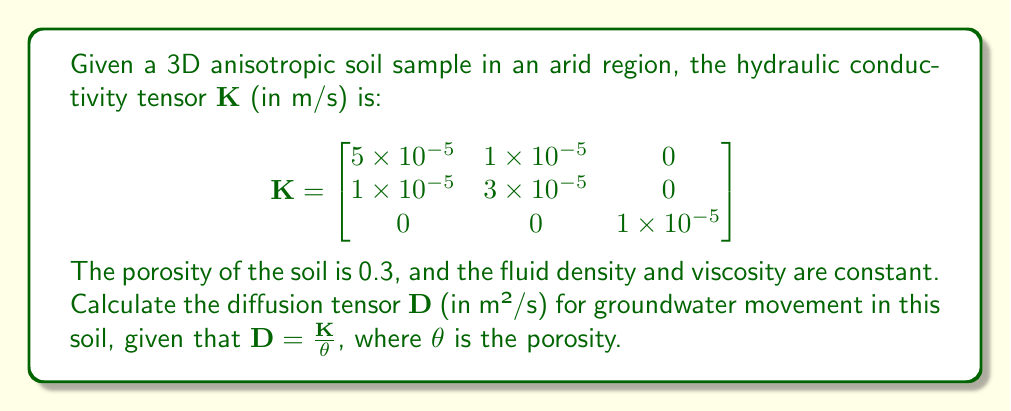Help me with this question. To solve this problem, we'll follow these steps:

1) Recall the relationship between the diffusion tensor $\mathbf{D}$ and the hydraulic conductivity tensor $\mathbf{K}$:

   $$\mathbf{D} = \frac{\mathbf{K}}{\theta}$$

   where $\theta$ is the porosity.

2) We're given that $\theta = 0.3$.

3) To calculate $\mathbf{D}$, we need to divide each element of $\mathbf{K}$ by $\theta$:

   $$\mathbf{D} = \frac{1}{0.3} \begin{bmatrix}
   5 \times 10^{-5} & 1 \times 10^{-5} & 0 \\
   1 \times 10^{-5} & 3 \times 10^{-5} & 0 \\
   0 & 0 & 1 \times 10^{-5}
   \end{bmatrix}$$

4) Performing the division:

   $$\mathbf{D} = \begin{bmatrix}
   \frac{5 \times 10^{-5}}{0.3} & \frac{1 \times 10^{-5}}{0.3} & 0 \\
   \frac{1 \times 10^{-5}}{0.3} & \frac{3 \times 10^{-5}}{0.3} & 0 \\
   0 & 0 & \frac{1 \times 10^{-5}}{0.3}
   \end{bmatrix}$$

5) Simplifying:

   $$\mathbf{D} = \begin{bmatrix}
   1.67 \times 10^{-4} & 3.33 \times 10^{-5} & 0 \\
   3.33 \times 10^{-5} & 1 \times 10^{-4} & 0 \\
   0 & 0 & 3.33 \times 10^{-5}
   \end{bmatrix}$$

This is the diffusion tensor for groundwater movement in the given arid soil sample, expressed in m²/s.
Answer: $$\mathbf{D} = \begin{bmatrix}
1.67 \times 10^{-4} & 3.33 \times 10^{-5} & 0 \\
3.33 \times 10^{-5} & 1 \times 10^{-4} & 0 \\
0 & 0 & 3.33 \times 10^{-5}
\end{bmatrix} \text{ m²/s}$$ 